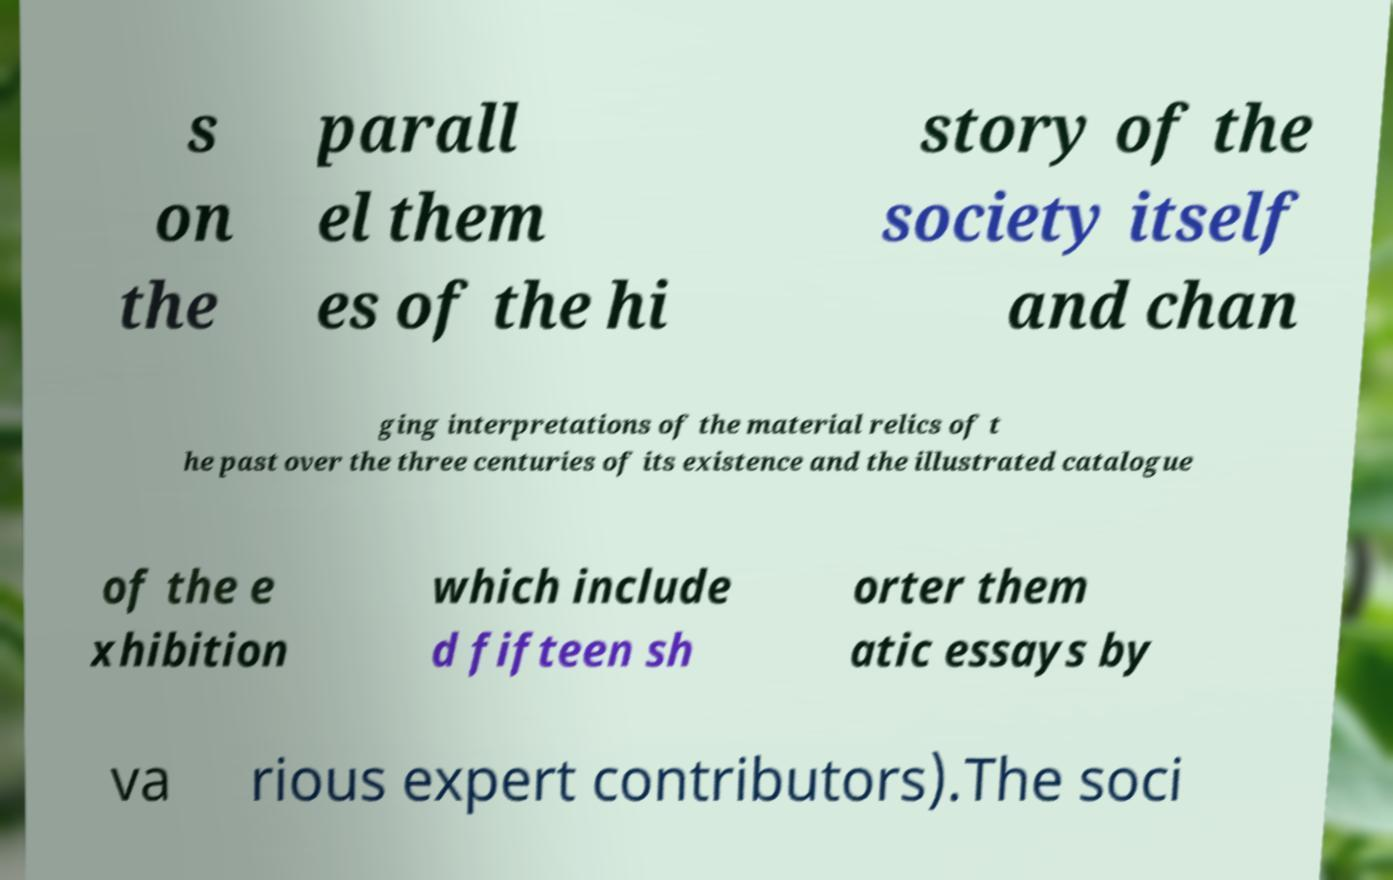Could you extract and type out the text from this image? s on the parall el them es of the hi story of the society itself and chan ging interpretations of the material relics of t he past over the three centuries of its existence and the illustrated catalogue of the e xhibition which include d fifteen sh orter them atic essays by va rious expert contributors).The soci 